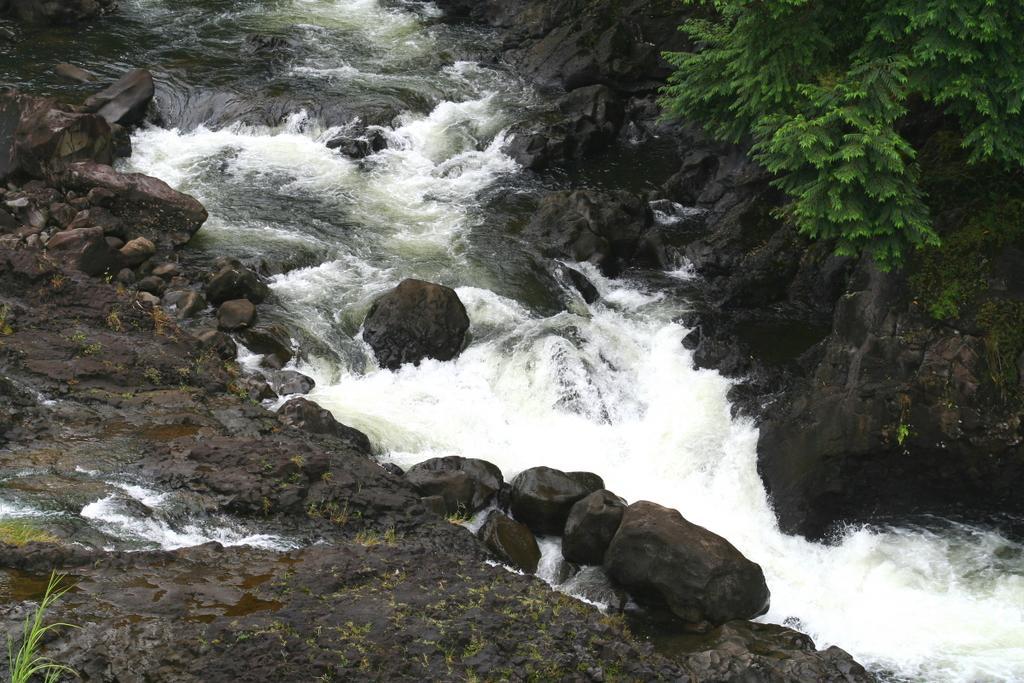Could you give a brief overview of what you see in this image? In this picture we can see rocks and water. In the top right corner of the image, there is a tree. In the bottom left corner of the image, there is a plant. On the rock surface, it looks like moss. 